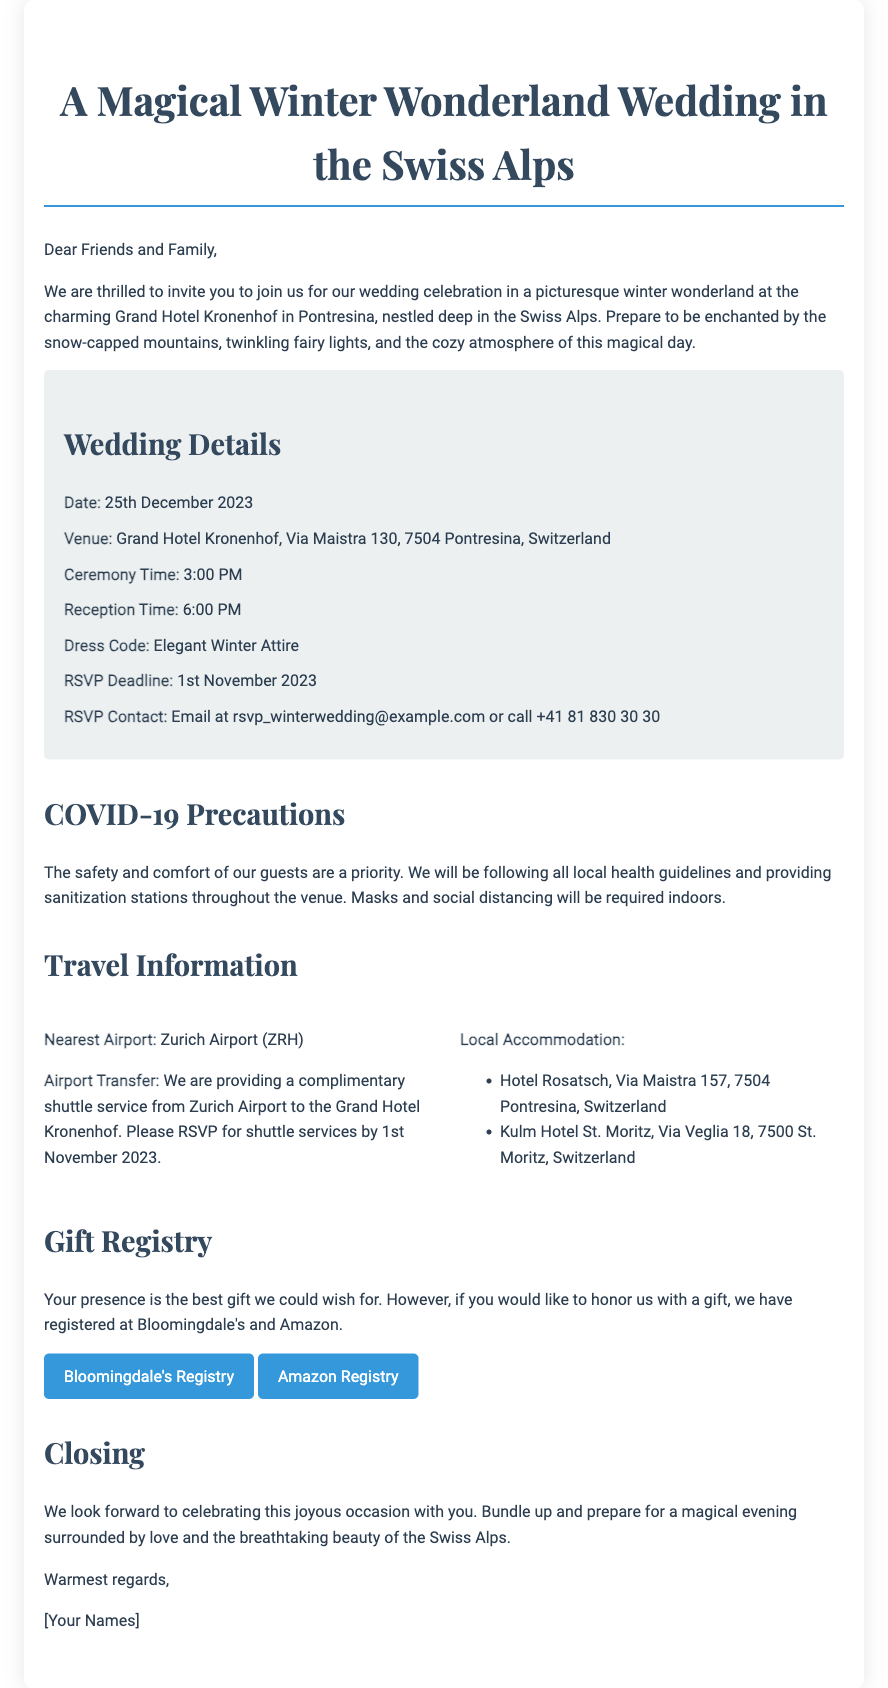What is the wedding date? The wedding date is specifically stated in the document as December 25, 2023.
Answer: December 25, 2023 What is the venue name? The venue name is highlighted in the details section as the Grand Hotel Kronenhof.
Answer: Grand Hotel Kronenhof What time does the ceremony start? The start time for the ceremony is indicated in the document as 3:00 PM.
Answer: 3:00 PM What is the dress code? The document specifies the dress code as "Elegant Winter Attire."
Answer: Elegant Winter Attire What is the RSVP deadline? The RSVP deadline is mentioned in the details section as November 1, 2023.
Answer: November 1, 2023 How many nearest airports are mentioned? The document states that only one nearest airport is mentioned, which is Zurich Airport.
Answer: One What precautions are in place for COVID-19? The document states that masks and social distancing will be required indoors as part of the precautions.
Answer: Masks and social distancing Which two stores are listed for the gift registry? The document lists Bloomingdale's and Amazon as the stores for the gift registry.
Answer: Bloomingdale's and Amazon What type of accommodation is provided? The document mentions local accommodation options, specifically Hotel Rosatsch and Kulm Hotel St. Moritz.
Answer: Hotel Rosatsch and Kulm Hotel St. Moritz 